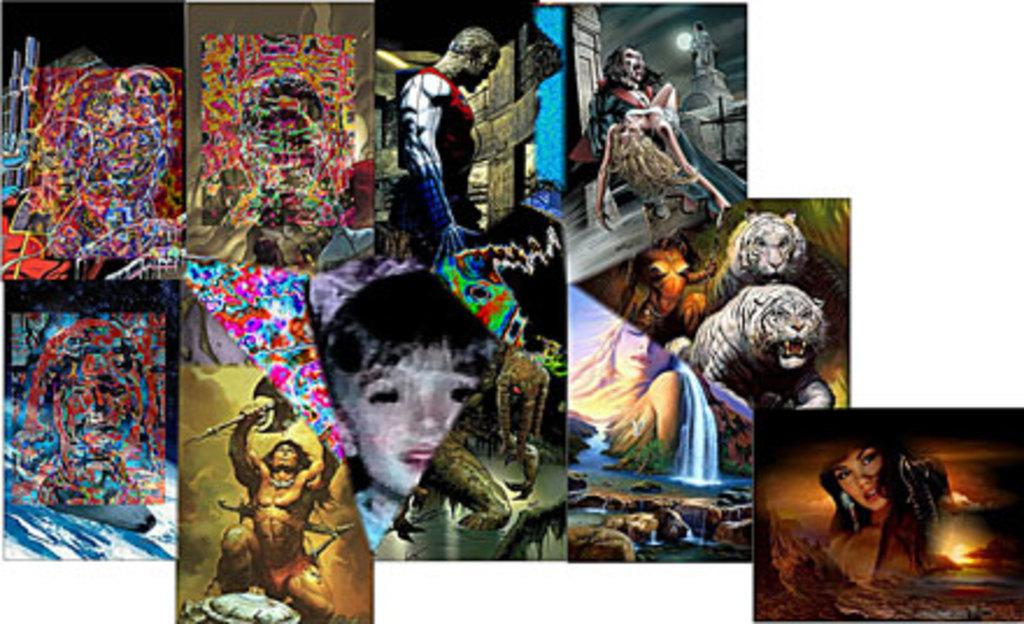What type of artwork is present in the image? There are wall paintings in the image. What subjects are depicted in the wall paintings? The wall paintings depict animals, human beings, water, and the sky. Can you describe the style or theme of the wall paintings? The wall paintings depict various subjects, including animals, human beings, water, and the sky, which suggests a nature or wildlife theme. What type of breakfast is being served in the image? There is no breakfast present in the image; it features wall paintings depicting various subjects. What type of sheet is covering the friend in the image? There is no friend or sheet present in the image; it features wall paintings depicting various subjects. 